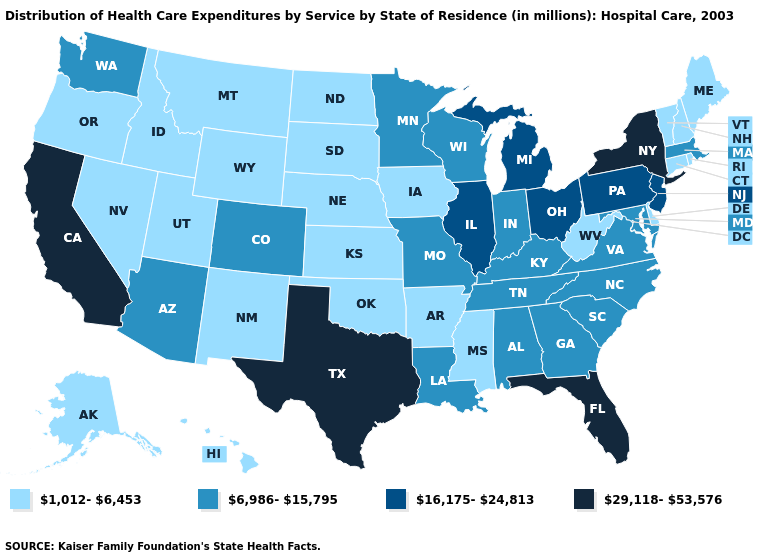Is the legend a continuous bar?
Quick response, please. No. What is the highest value in the USA?
Be succinct. 29,118-53,576. Is the legend a continuous bar?
Give a very brief answer. No. How many symbols are there in the legend?
Answer briefly. 4. Is the legend a continuous bar?
Short answer required. No. Which states have the lowest value in the USA?
Be succinct. Alaska, Arkansas, Connecticut, Delaware, Hawaii, Idaho, Iowa, Kansas, Maine, Mississippi, Montana, Nebraska, Nevada, New Hampshire, New Mexico, North Dakota, Oklahoma, Oregon, Rhode Island, South Dakota, Utah, Vermont, West Virginia, Wyoming. Does the first symbol in the legend represent the smallest category?
Give a very brief answer. Yes. Does the first symbol in the legend represent the smallest category?
Quick response, please. Yes. How many symbols are there in the legend?
Concise answer only. 4. Does Florida have a higher value than Texas?
Concise answer only. No. Does Nebraska have a lower value than Connecticut?
Be succinct. No. What is the lowest value in the Northeast?
Answer briefly. 1,012-6,453. Does West Virginia have the highest value in the South?
Quick response, please. No. What is the value of Nevada?
Quick response, please. 1,012-6,453. Name the states that have a value in the range 29,118-53,576?
Quick response, please. California, Florida, New York, Texas. 